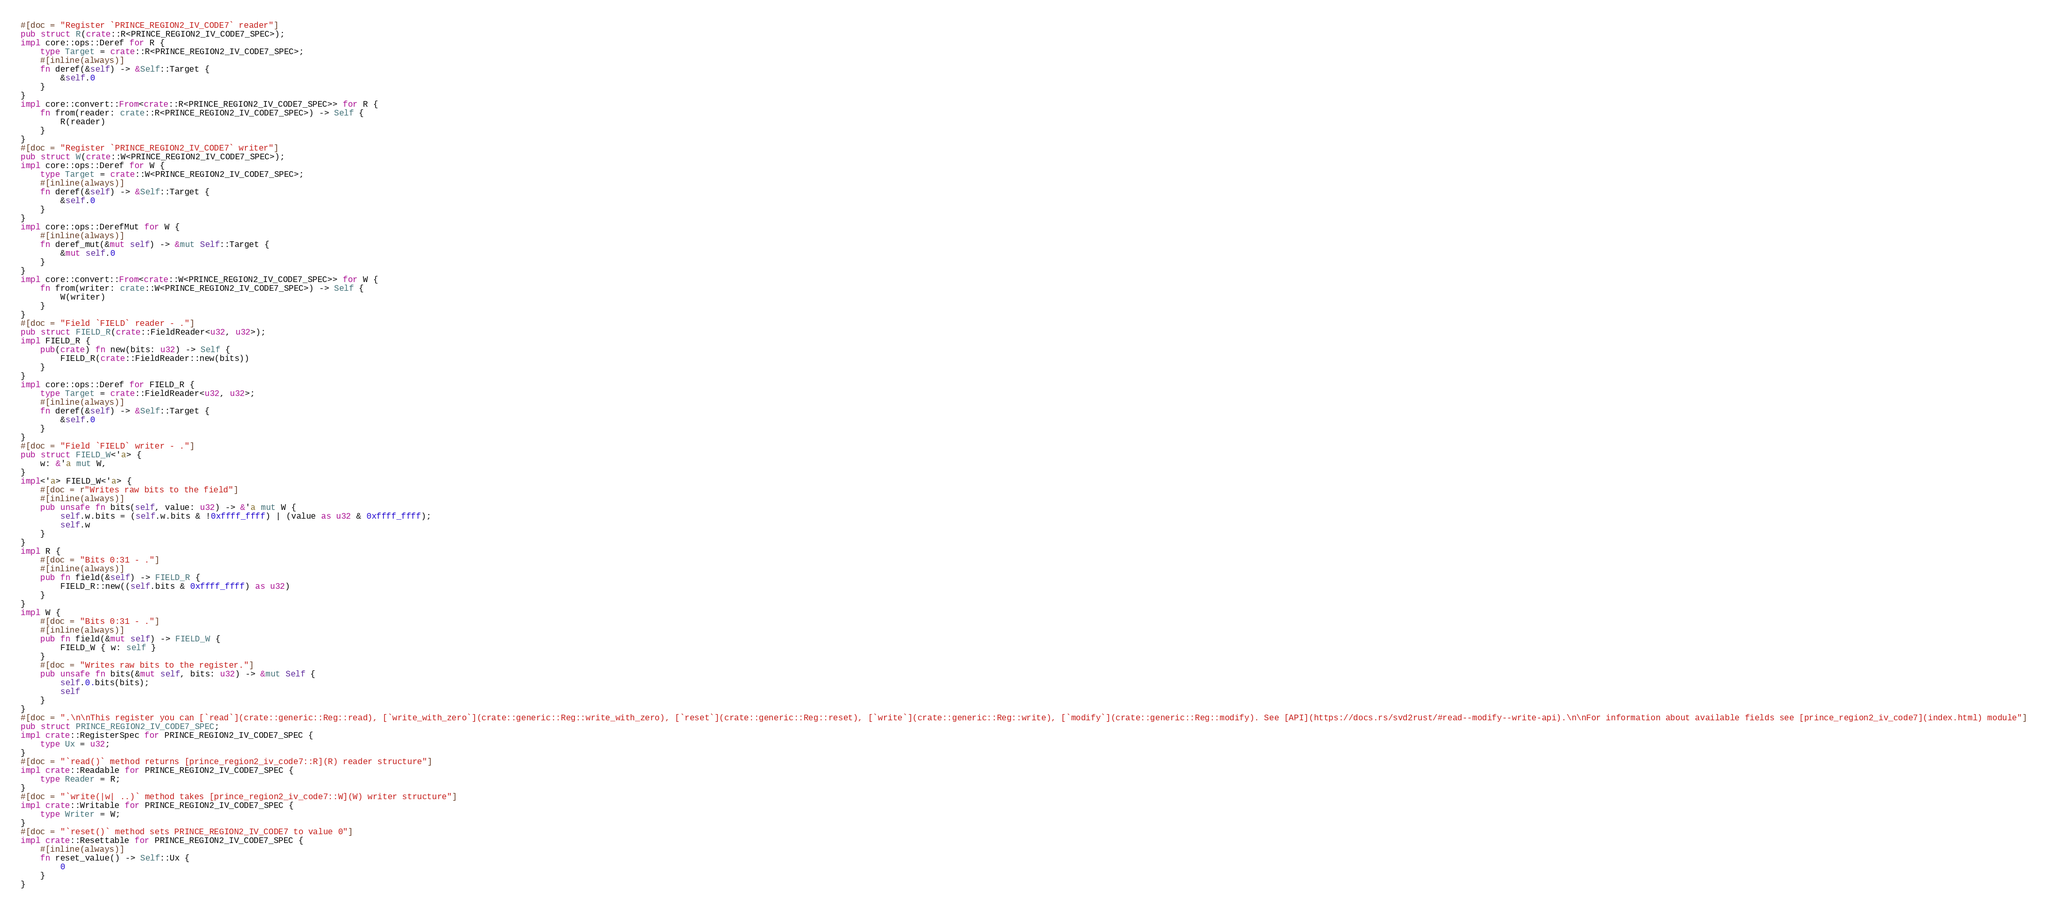Convert code to text. <code><loc_0><loc_0><loc_500><loc_500><_Rust_>#[doc = "Register `PRINCE_REGION2_IV_CODE7` reader"]
pub struct R(crate::R<PRINCE_REGION2_IV_CODE7_SPEC>);
impl core::ops::Deref for R {
    type Target = crate::R<PRINCE_REGION2_IV_CODE7_SPEC>;
    #[inline(always)]
    fn deref(&self) -> &Self::Target {
        &self.0
    }
}
impl core::convert::From<crate::R<PRINCE_REGION2_IV_CODE7_SPEC>> for R {
    fn from(reader: crate::R<PRINCE_REGION2_IV_CODE7_SPEC>) -> Self {
        R(reader)
    }
}
#[doc = "Register `PRINCE_REGION2_IV_CODE7` writer"]
pub struct W(crate::W<PRINCE_REGION2_IV_CODE7_SPEC>);
impl core::ops::Deref for W {
    type Target = crate::W<PRINCE_REGION2_IV_CODE7_SPEC>;
    #[inline(always)]
    fn deref(&self) -> &Self::Target {
        &self.0
    }
}
impl core::ops::DerefMut for W {
    #[inline(always)]
    fn deref_mut(&mut self) -> &mut Self::Target {
        &mut self.0
    }
}
impl core::convert::From<crate::W<PRINCE_REGION2_IV_CODE7_SPEC>> for W {
    fn from(writer: crate::W<PRINCE_REGION2_IV_CODE7_SPEC>) -> Self {
        W(writer)
    }
}
#[doc = "Field `FIELD` reader - ."]
pub struct FIELD_R(crate::FieldReader<u32, u32>);
impl FIELD_R {
    pub(crate) fn new(bits: u32) -> Self {
        FIELD_R(crate::FieldReader::new(bits))
    }
}
impl core::ops::Deref for FIELD_R {
    type Target = crate::FieldReader<u32, u32>;
    #[inline(always)]
    fn deref(&self) -> &Self::Target {
        &self.0
    }
}
#[doc = "Field `FIELD` writer - ."]
pub struct FIELD_W<'a> {
    w: &'a mut W,
}
impl<'a> FIELD_W<'a> {
    #[doc = r"Writes raw bits to the field"]
    #[inline(always)]
    pub unsafe fn bits(self, value: u32) -> &'a mut W {
        self.w.bits = (self.w.bits & !0xffff_ffff) | (value as u32 & 0xffff_ffff);
        self.w
    }
}
impl R {
    #[doc = "Bits 0:31 - ."]
    #[inline(always)]
    pub fn field(&self) -> FIELD_R {
        FIELD_R::new((self.bits & 0xffff_ffff) as u32)
    }
}
impl W {
    #[doc = "Bits 0:31 - ."]
    #[inline(always)]
    pub fn field(&mut self) -> FIELD_W {
        FIELD_W { w: self }
    }
    #[doc = "Writes raw bits to the register."]
    pub unsafe fn bits(&mut self, bits: u32) -> &mut Self {
        self.0.bits(bits);
        self
    }
}
#[doc = ".\n\nThis register you can [`read`](crate::generic::Reg::read), [`write_with_zero`](crate::generic::Reg::write_with_zero), [`reset`](crate::generic::Reg::reset), [`write`](crate::generic::Reg::write), [`modify`](crate::generic::Reg::modify). See [API](https://docs.rs/svd2rust/#read--modify--write-api).\n\nFor information about available fields see [prince_region2_iv_code7](index.html) module"]
pub struct PRINCE_REGION2_IV_CODE7_SPEC;
impl crate::RegisterSpec for PRINCE_REGION2_IV_CODE7_SPEC {
    type Ux = u32;
}
#[doc = "`read()` method returns [prince_region2_iv_code7::R](R) reader structure"]
impl crate::Readable for PRINCE_REGION2_IV_CODE7_SPEC {
    type Reader = R;
}
#[doc = "`write(|w| ..)` method takes [prince_region2_iv_code7::W](W) writer structure"]
impl crate::Writable for PRINCE_REGION2_IV_CODE7_SPEC {
    type Writer = W;
}
#[doc = "`reset()` method sets PRINCE_REGION2_IV_CODE7 to value 0"]
impl crate::Resettable for PRINCE_REGION2_IV_CODE7_SPEC {
    #[inline(always)]
    fn reset_value() -> Self::Ux {
        0
    }
}
</code> 